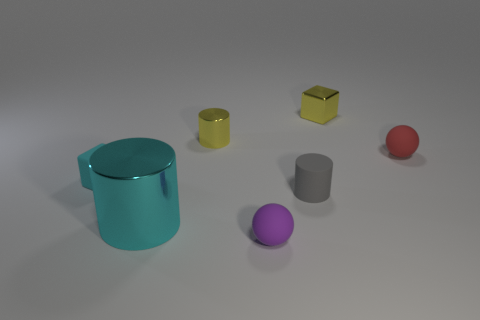There is a object that is the same color as the small rubber block; what is its size?
Your answer should be compact. Large. There is a object that is the same color as the metallic block; what shape is it?
Ensure brevity in your answer.  Cylinder. Do the tiny metal cube and the tiny metal thing in front of the small yellow block have the same color?
Give a very brief answer. Yes. There is a large cylinder that is the same color as the tiny rubber cube; what is its material?
Your response must be concise. Metal. What is the shape of the shiny object that is right of the ball that is to the left of the ball behind the cyan metal cylinder?
Ensure brevity in your answer.  Cube. What is the shape of the small cyan matte object?
Your answer should be compact. Cube. There is a shiny object that is in front of the small gray thing; what color is it?
Offer a terse response. Cyan. Does the cyan object that is on the right side of the cyan matte block have the same size as the yellow metal cylinder?
Your response must be concise. No. What size is the other shiny object that is the same shape as the cyan metallic thing?
Your answer should be compact. Small. Is there anything else that is the same size as the cyan cylinder?
Ensure brevity in your answer.  No. 